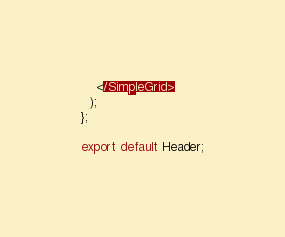<code> <loc_0><loc_0><loc_500><loc_500><_TypeScript_>    </SimpleGrid>
  );
};

export default Header;
</code> 